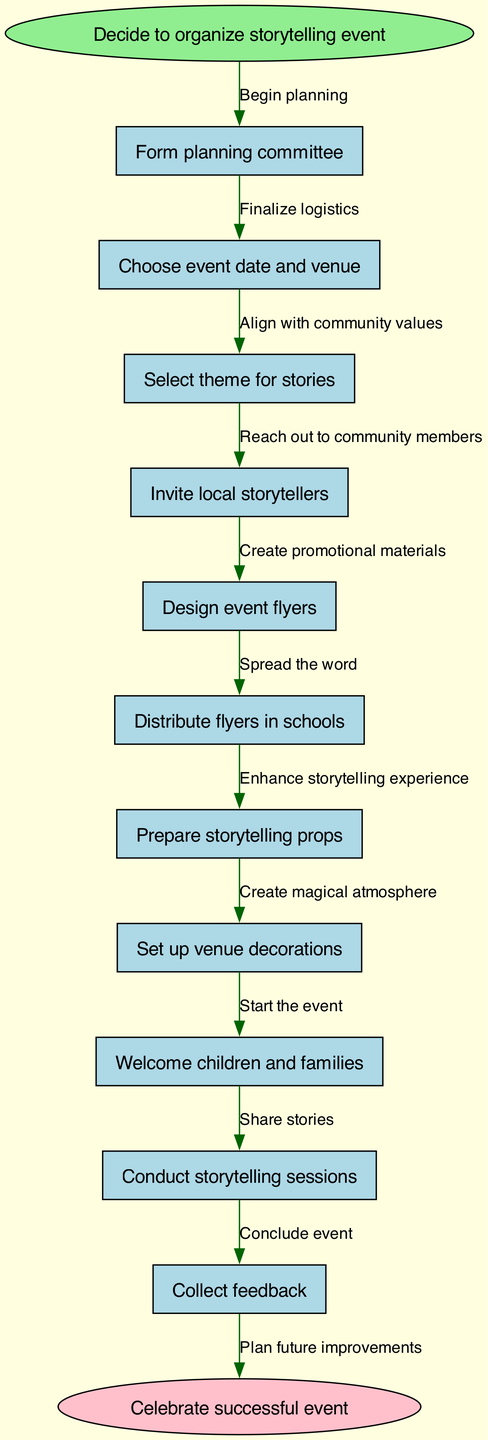What is the first step in the flowchart? The first step is the "Decide to organize storytelling event," which is indicated as the start node in the diagram.
Answer: Decide to organize storytelling event How many nodes are there in the flowchart? Counting all the nodes listed in the data, there are 11 nodes including the start and end nodes.
Answer: 11 What is the last action before the event ends? The last action before concluding the event is "Collect feedback," which is connected to the ending node in the diagram.
Answer: Collect feedback Which node follows "Invite local storytellers"? The node that follows "Invite local storytellers" is "Design event flyers," as indicated by the directed edge connecting those two nodes.
Answer: Design event flyers What is the color of the start node? The start node is colored light green, as specified in the node attributes of the diagram.
Answer: Light green What action is taken after "Set up venue decorations"? The action taken after "Set up venue decorations" is "Welcome children and families," as shown by the connection from one node to the next.
Answer: Welcome children and families What is the relationship between "Choose event date and venue" and "Finalize logistics"? "Choose event date and venue" is the action taken that leads to "Finalize logistics," indicating a sequential step in the planning process represented by a directed edge.
Answer: Finalize logistics How many edges are there in total? There are 10 edges in total, corresponding to the connections between the 10 nodes in the flowchart, leading to the end node.
Answer: 10 What is the theme for stories selected before "Conduct storytelling sessions"? The theme for stories is selected in the "Select theme for stories" node, which is a prerequisite for conducting the storytelling sessions.
Answer: Select theme for stories What is the purpose of "Design event flyers"? The purpose of "Design event flyers" is to create promotional materials that will help to inform and attract attendees to the event.
Answer: Create promotional materials 